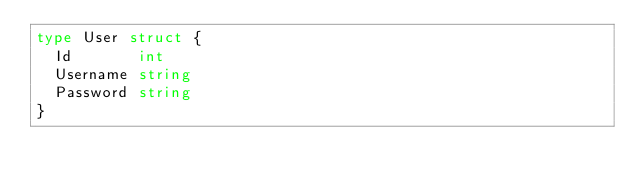<code> <loc_0><loc_0><loc_500><loc_500><_Go_>type User struct {
	Id       int
	Username string
	Password string
}
</code> 